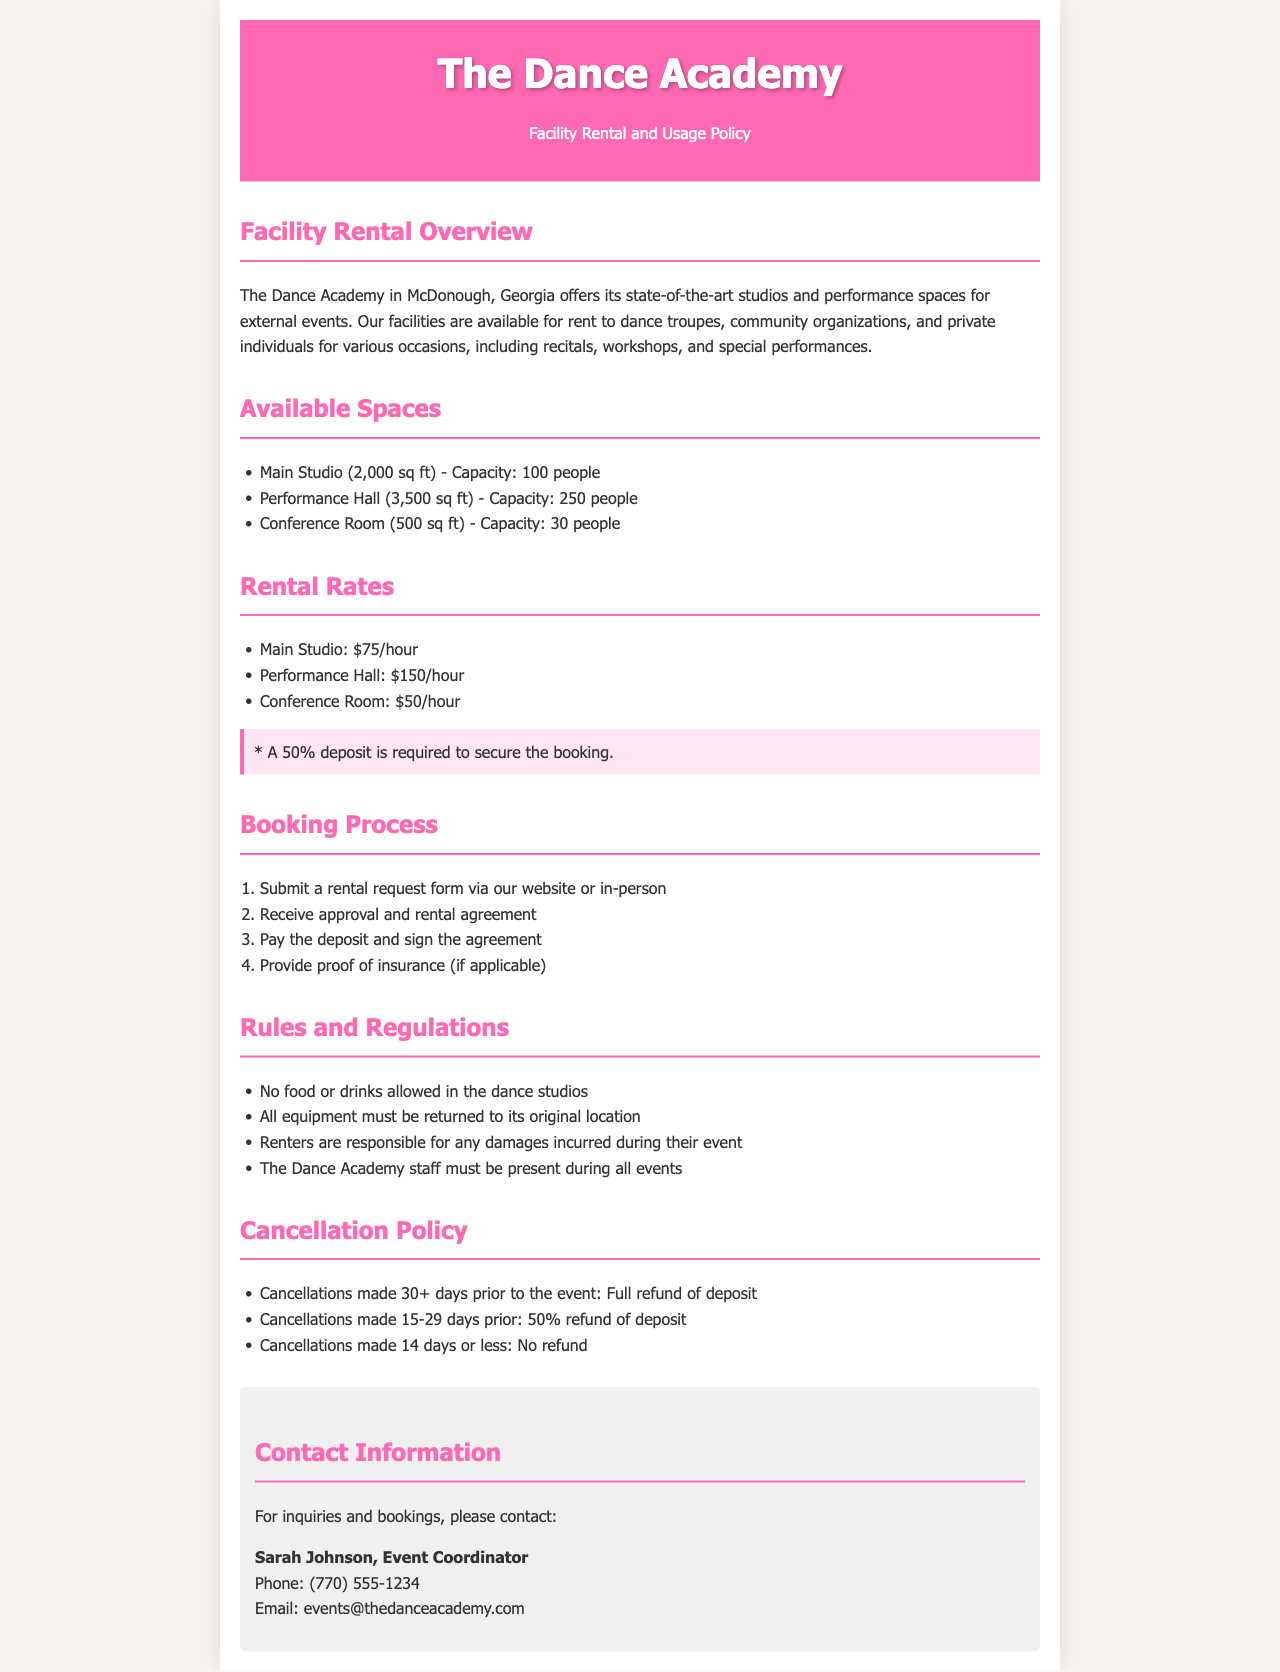what is the capacity of the Main Studio? The Main Studio has a capacity of 100 people as stated in the document.
Answer: 100 people how much does it cost to rent the Performance Hall per hour? The rental rate for the Performance Hall is mentioned as $150 per hour in the document.
Answer: $150/hour what is required to secure a booking? A 50% deposit is required to secure the booking according to the rental rates section.
Answer: 50% deposit who is the Event Coordinator at The Dance Academy? Sarah Johnson is identified as the Event Coordinator in the contact information section.
Answer: Sarah Johnson what is the refund policy for cancellations made 15-29 days prior to the event? The document states that cancellations made 15-29 days prior will receive a 50% refund of the deposit.
Answer: 50% refund how many spaces are available for rent at The Dance Academy? The document lists three available spaces: Main Studio, Performance Hall, and Conference Room.
Answer: Three what must renters provide if applicable? Renters are required to provide proof of insurance if applicable as stated in the booking process.
Answer: Proof of insurance what are the main restrictions regarding food and drinks? The document specifies that no food or drinks are allowed in the dance studios.
Answer: No food or drinks allowed what must be done if damages occur during an event? Renters are responsible for any damages incurred during their event according to the rules and regulations section.
Answer: Renters are responsible for damages 